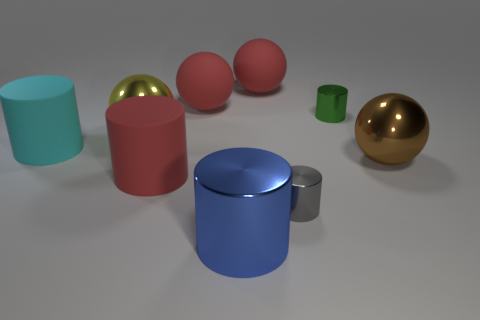Subtract all blue cylinders. How many cylinders are left? 4 Subtract all blue metallic cylinders. How many cylinders are left? 4 Subtract 1 red cylinders. How many objects are left? 8 Subtract all cylinders. How many objects are left? 4 Subtract 1 cylinders. How many cylinders are left? 4 Subtract all green cylinders. Subtract all purple balls. How many cylinders are left? 4 Subtract all brown cylinders. How many green spheres are left? 0 Subtract all cyan shiny things. Subtract all big brown metal balls. How many objects are left? 8 Add 8 big yellow things. How many big yellow things are left? 9 Add 1 large rubber spheres. How many large rubber spheres exist? 3 